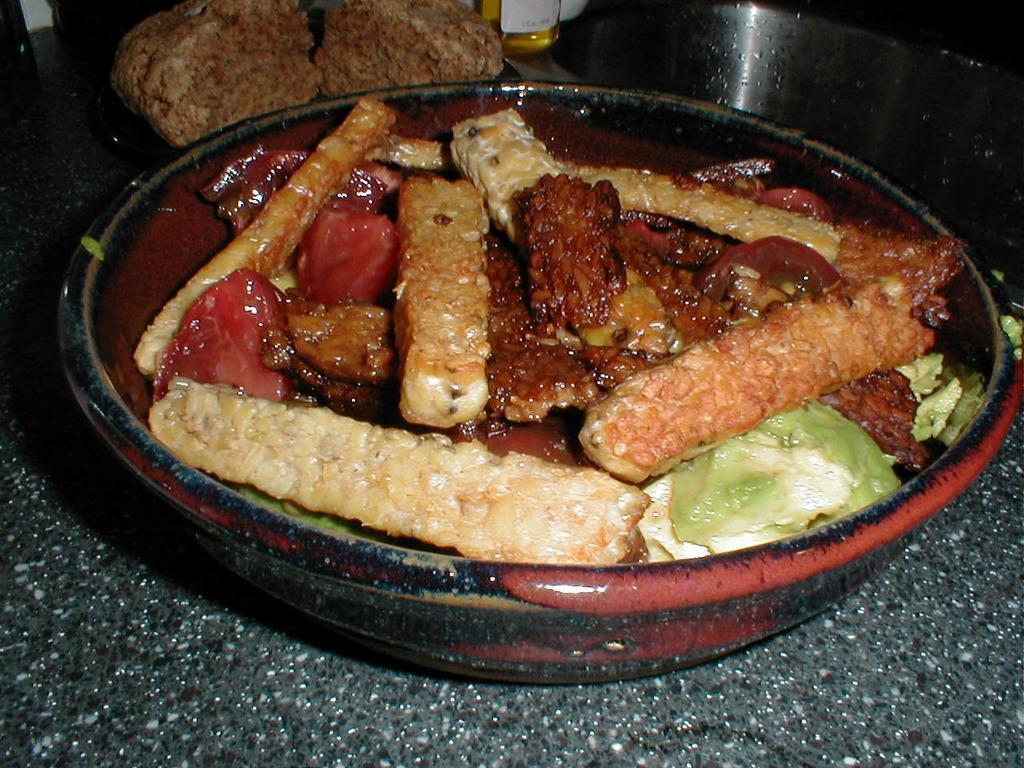Please provide a concise description of this image. In this image I can see food which is in brown, red and green color in the bowl and the bowl is in black and brown color. 